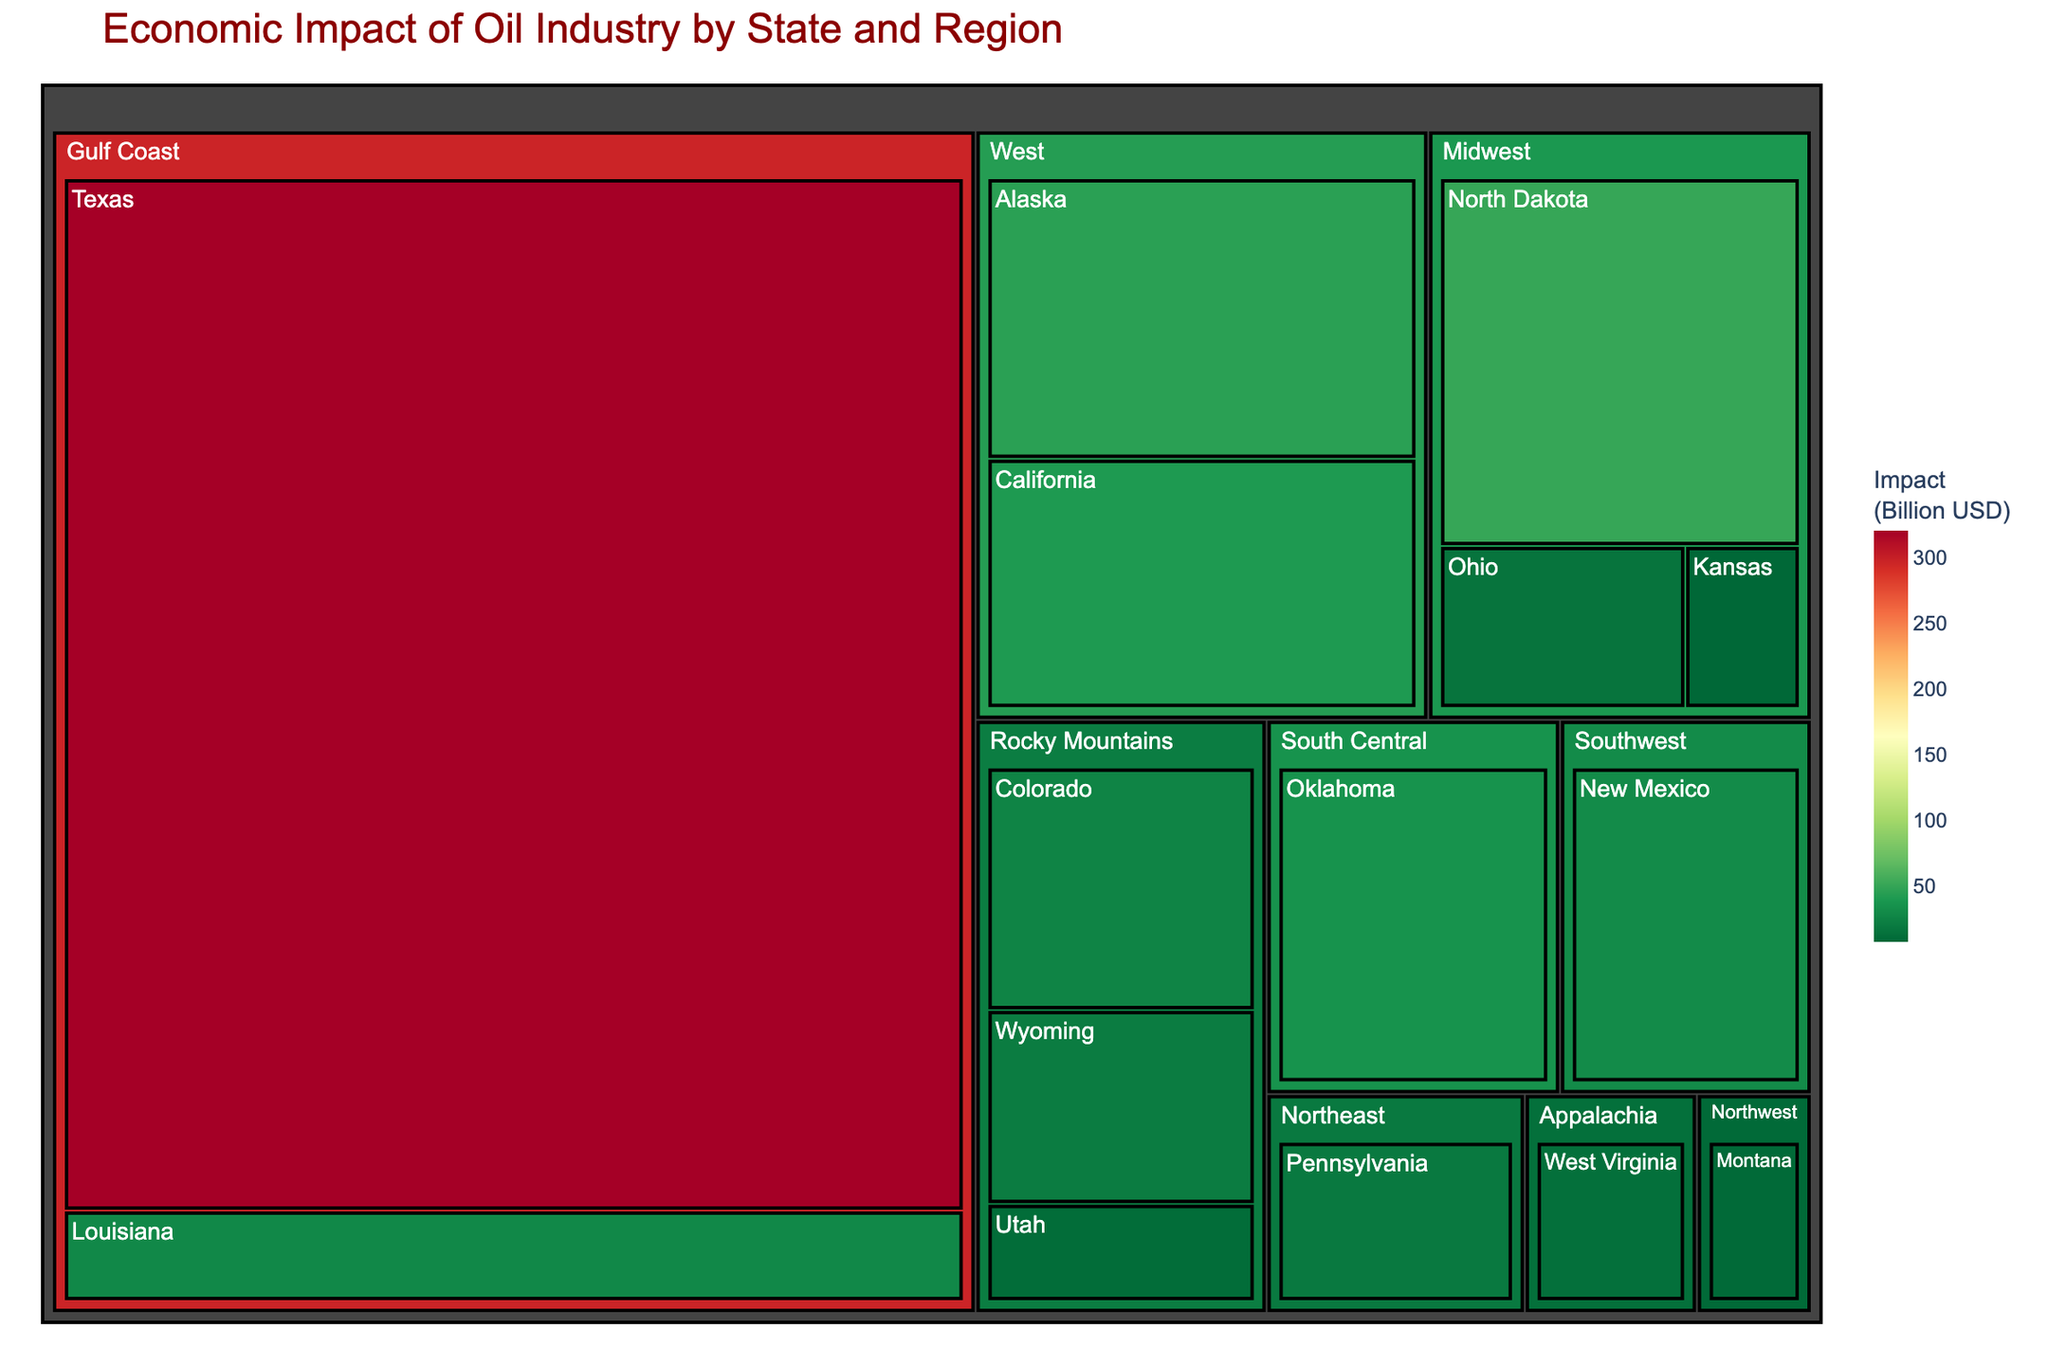What's the title of the figure? The title of the figure is prominently displayed at the top, using larger and bold font size. It indicates the main subject of the visualization, which is "Economic Impact of Oil Industry by State and Region".
Answer: Economic Impact of Oil Industry by State and Region Which state has the largest economic impact from the oil industry? By examining the size of the rectangles in the Treemap, Texas shows the largest rectangle, indicating that it has the highest economic impact among the states.
Answer: Texas What is the combined economic impact of the Rocky Mountains region? Summing the economic impacts of Colorado, Wyoming, and Utah from the Rocky Mountains region: 25 + 20 + 10 = 55 Billion USD.
Answer: 55 Billion USD How does the economic impact of Texas compare to North Dakota? Texas has an economic impact of 320 Billion USD, whereas North Dakota has 50 Billion USD. Thus, Texas's impact is greater.
Answer: Texas has a greater impact than North Dakota Which region has the second-highest economic impact after the Gulf Coast? The Gulf Coast includes Texas and Louisiana with a high total impact. The next largest region by size of the rectang trio is the Midwest, comprising North Dakota, Ohio, and Kansas.
Answer: Midwest How many states have an economic impact of over 30 Billion USD? We identify Texas, North Dakota, Alaska, California, Oklahoma, and New Mexico as the states with rectangle sizes corresponding to over 30 Billion USD economic impact.
Answer: 6 Is Alaska's economic impact higher or lower than California's? From the Treemap, the size of Alaska's rectangle is slightly larger than California's, indicating a higher economic impact.
Answer: Higher Which regions encompass exactly three states? Examining the Treemap within each region block, Rocky Mountains and Midwest regions each encompass three states.
Answer: Rocky Mountains and Midwest What's the average economic impact of the states in the Northeast region? Only one state, Pennsylvania, represents the Northeast with an economic impact of 18 Billion USD. Thus, the average is 18 / 1 = 18 Billion USD.
Answer: 18 Billion USD What is the total economic impact of the oil industry in the West region? Summing the economic impacts of Alaska and California in the West region: 45 + 40 = 85 Billion USD.
Answer: 85 Billion USD 